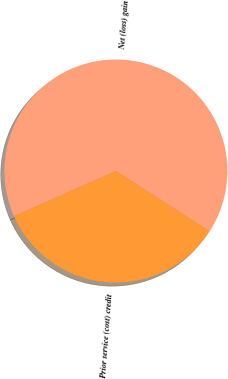Convert chart to OTSL. <chart><loc_0><loc_0><loc_500><loc_500><pie_chart><fcel>Net (loss) gain<fcel>Prior service (cost) credit<nl><fcel>65.74%<fcel>34.26%<nl></chart> 